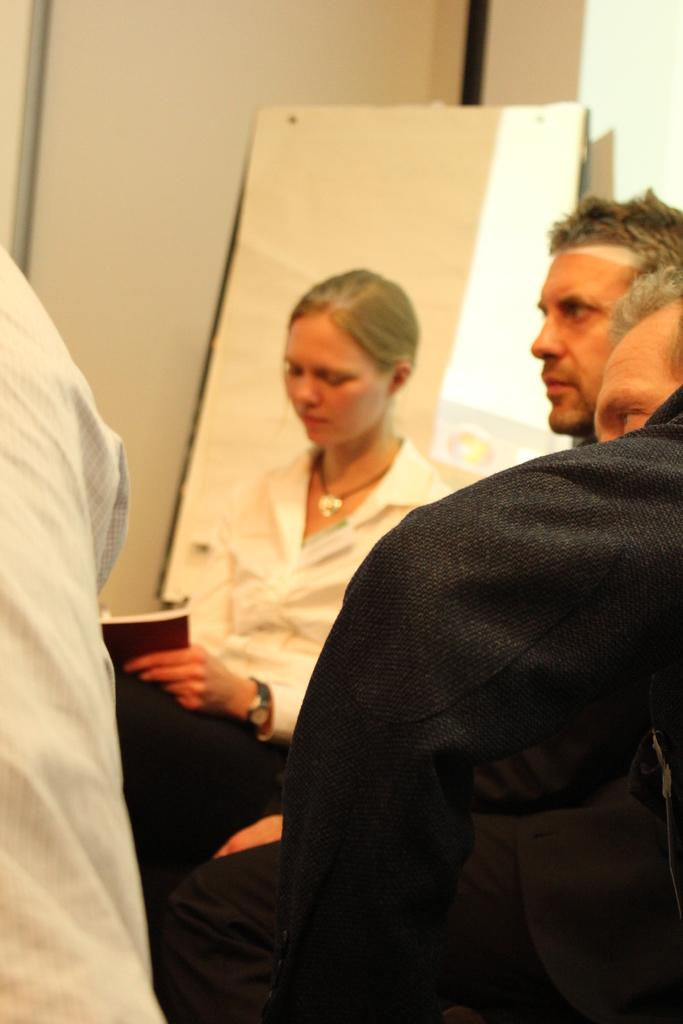How many people are in the image? There is a group of people in the image. Can you describe the woman in the center of the group? The woman is sitting in the center of the group and is holding a book. What can be seen in the background of the image? There is a board and a wall in the background of the image. Can you tell me how many lakes are visible in the image? There are no lakes visible in the image; it features a group of people with a woman holding a book and a background with a board and a wall. 